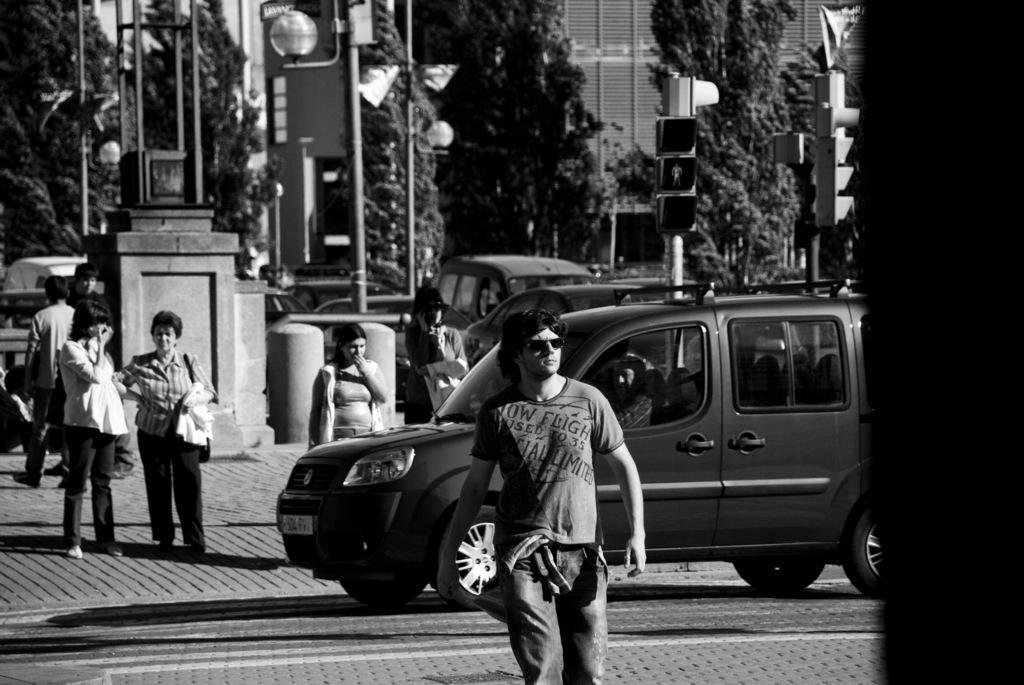Can you describe this image briefly? In this image in the front there is a person walking. In the center there is a car moving on the road. In the background there are persons standing, there are cars, poles, trees and there is a building. 